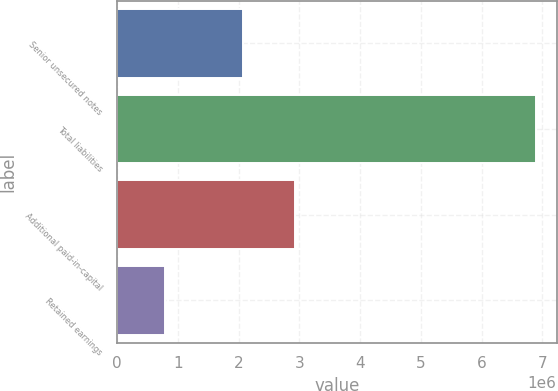Convert chart to OTSL. <chart><loc_0><loc_0><loc_500><loc_500><bar_chart><fcel>Senior unsecured notes<fcel>Total liabilities<fcel>Additional paid-in-capital<fcel>Retained earnings<nl><fcel>2.06994e+06<fcel>6.8888e+06<fcel>2.93189e+06<fcel>791861<nl></chart> 